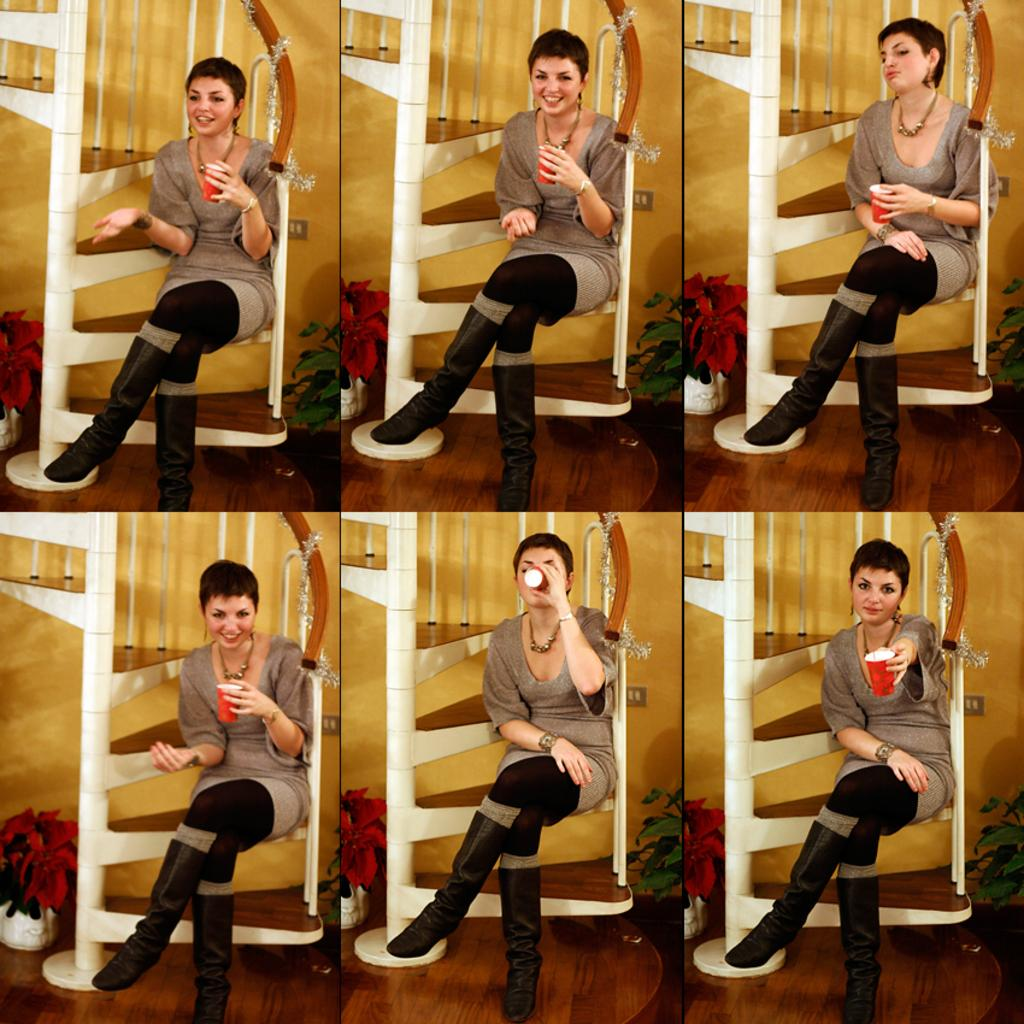What is the woman doing in the image? The woman is sitting on the stairs and drinking from a glass in the image. What is the woman holding in the image? The woman is holding a glass in the image. What can be seen in pots in the image? There are plants in pots in the image. What is visible in the background of the image? There is a wall in the background of the image. What book is the woman reading in the image? There is no book present in the image; the woman is holding a glass and drinking from it. 